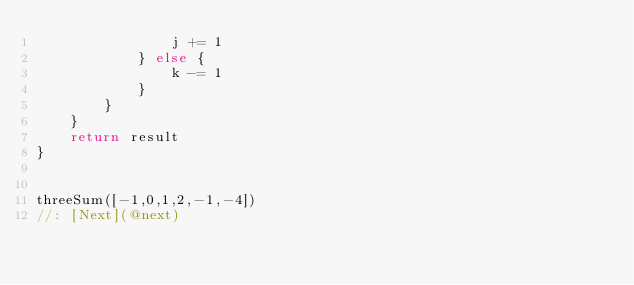<code> <loc_0><loc_0><loc_500><loc_500><_Swift_>                j += 1
            } else {
                k -= 1
            }
        }
    }
    return result
}


threeSum([-1,0,1,2,-1,-4])
//: [Next](@next)
</code> 